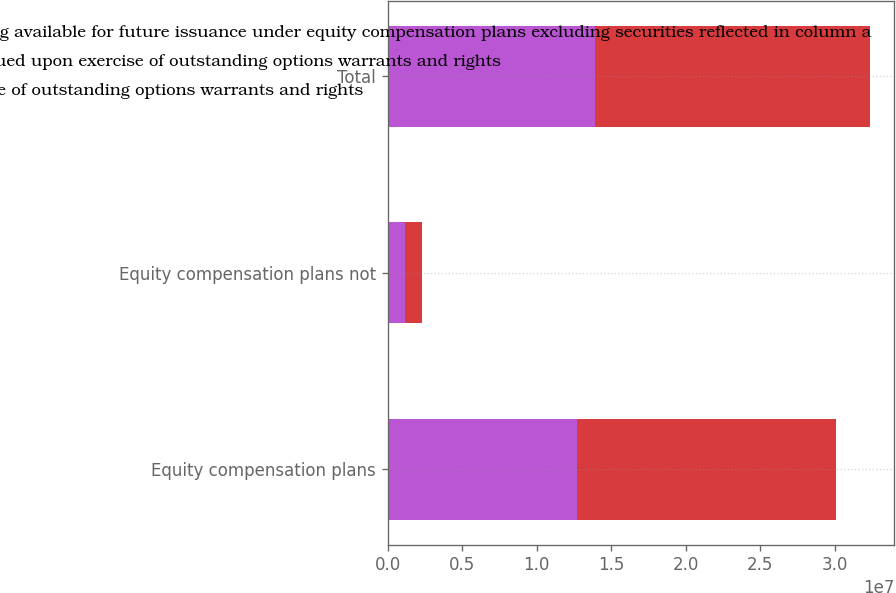<chart> <loc_0><loc_0><loc_500><loc_500><stacked_bar_chart><ecel><fcel>Equity compensation plans<fcel>Equity compensation plans not<fcel>Total<nl><fcel>c Number of securities remaining available for future issuance under equity compensation plans excluding securities reflected in column a<fcel>1.27066e+07<fcel>1.1825e+06<fcel>1.38891e+07<nl><fcel>a Number of securities to be issued upon exercise of outstanding options warrants and rights<fcel>43.23<fcel>43.62<fcel>43.26<nl><fcel>b Weightedaverage exercise price of outstanding options warrants and rights<fcel>1.73495e+07<fcel>1.14768e+06<fcel>1.84972e+07<nl></chart> 